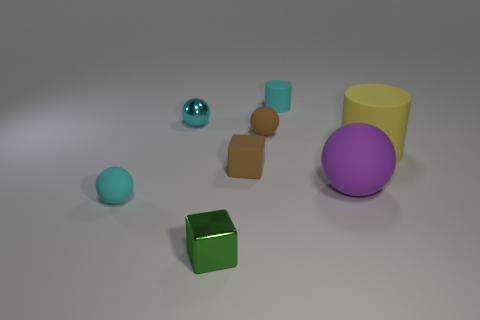Add 1 small cubes. How many objects exist? 9 Subtract all small spheres. How many spheres are left? 1 Subtract 1 cubes. How many cubes are left? 1 Subtract all yellow cylinders. How many cylinders are left? 1 Subtract 1 cyan cylinders. How many objects are left? 7 Subtract all purple cylinders. Subtract all purple balls. How many cylinders are left? 2 Subtract all brown cylinders. How many blue balls are left? 0 Subtract all tiny green objects. Subtract all small rubber cylinders. How many objects are left? 6 Add 1 cyan things. How many cyan things are left? 4 Add 5 big yellow matte cylinders. How many big yellow matte cylinders exist? 6 